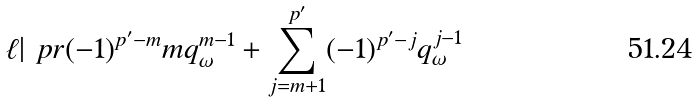Convert formula to latex. <formula><loc_0><loc_0><loc_500><loc_500>\ell | \ p r { ( - 1 ) ^ { p ^ { \prime } - m } m q _ { \omega } ^ { m - 1 } + \sum _ { j = m + 1 } ^ { p ^ { \prime } } ( - 1 ) ^ { p ^ { \prime } - j } q _ { \omega } ^ { j - 1 } }</formula> 